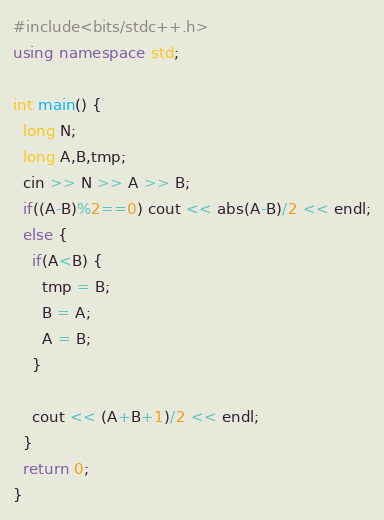<code> <loc_0><loc_0><loc_500><loc_500><_C++_>#include<bits/stdc++.h>
using namespace std;

int main() {
  long N;
  long A,B,tmp;
  cin >> N >> A >> B;
  if((A-B)%2==0) cout << abs(A-B)/2 << endl;
  else {
    if(A<B) {
      tmp = B;
      B = A;
      A = B;
    }

    cout << (A+B+1)/2 << endl;
  }
  return 0;
}
</code> 